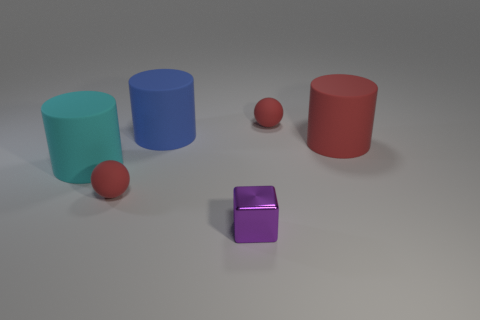Is there any other thing that is the same material as the small cube?
Your response must be concise. No. How many big red rubber things are the same shape as the small purple thing?
Give a very brief answer. 0. How many cyan rubber cylinders have the same size as the blue thing?
Offer a very short reply. 1. There is a red thing that is the same shape as the big blue object; what is its material?
Make the answer very short. Rubber. What color is the small sphere on the right side of the purple thing?
Your answer should be compact. Red. Is the number of small cubes to the right of the cyan rubber cylinder greater than the number of big green shiny blocks?
Your answer should be compact. Yes. What color is the shiny block?
Provide a short and direct response. Purple. What shape is the thing right of the rubber ball behind the big matte cylinder in front of the big red rubber cylinder?
Offer a terse response. Cylinder. There is a large object that is in front of the large blue cylinder and to the right of the cyan cylinder; what is its material?
Make the answer very short. Rubber. The tiny red object that is on the right side of the sphere that is on the left side of the metallic object is what shape?
Offer a terse response. Sphere. 